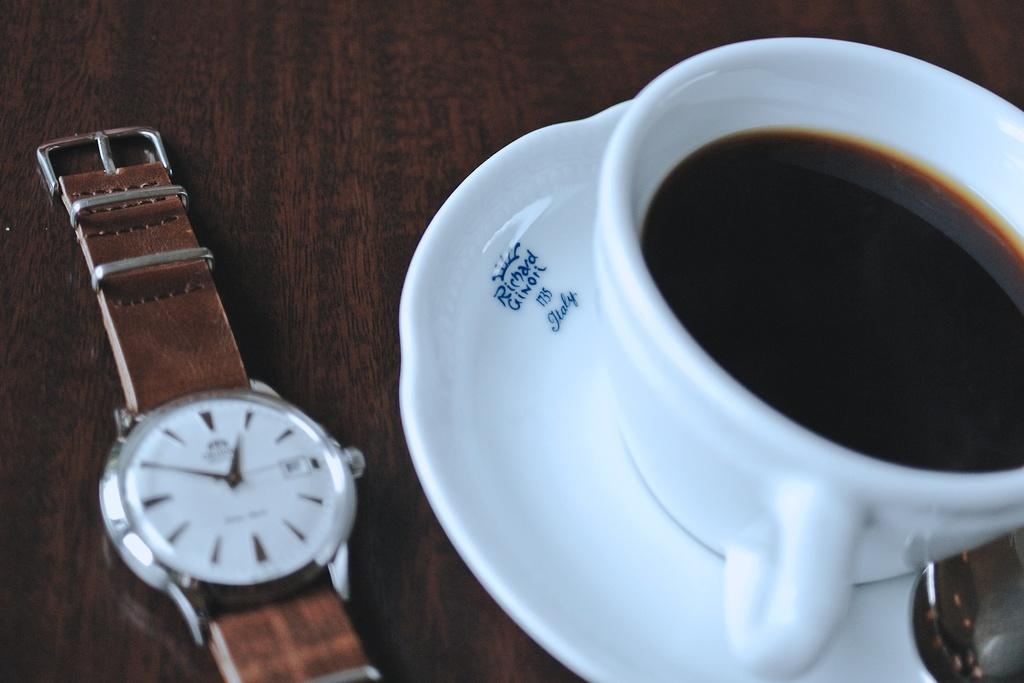<image>
Describe the image concisely. A watch is next to a cup of coffee and saucer that says Richard Ginori 1735 Italy. 